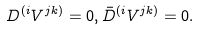Convert formula to latex. <formula><loc_0><loc_0><loc_500><loc_500>D ^ { ( i } V ^ { j k ) } = 0 , \bar { D } ^ { ( i } V ^ { j k ) } = 0 .</formula> 